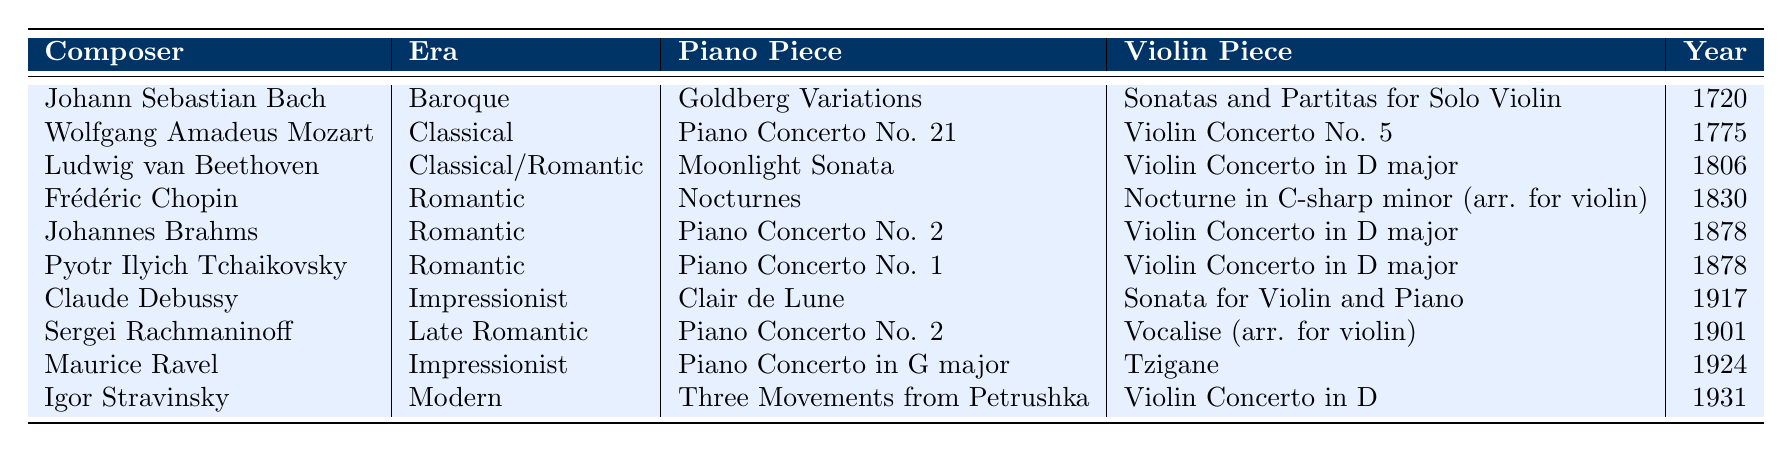What composer created the "Moonlight Sonata"? By looking at the table, I can see that "Moonlight Sonata" is associated with Ludwig van Beethoven.
Answer: Ludwig van Beethoven In which era was the "Violin Concerto in D major" composed? The table lists "Violin Concerto in D major" under both Johannes Brahms and Pyotr Ilyich Tchaikovsky, who are both in the Romantic era.
Answer: Romantic Which piece for piano was composed in 1830? Referring to the table, I find that Frédéric Chopin's "Nocturnes" was composed in 1830.
Answer: Nocturnes Who is the composer of "Clair de Lune"? The table indicates that "Clair de Lune" is by Claude Debussy.
Answer: Claude Debussy What is the earliest composition listed in the table? Checking the "Year" column, I see that Johann Sebastian Bach's "Goldberg Variations," composed in 1720, is the earliest.
Answer: 1720 Which composer has two major works listed in the table? By reviewing the entries, I find that "Violin Concerto in D major" appears for both Johannes Brahms and Pyotr Ilyich Tchaikovsky, indicating that both have two major works.
Answer: Johannes Brahms and Pyotr Ilyich Tchaikovsky Are there any composers in the table from the Impressionist era? The table mentions Claude Debussy and Maurice Ravel, both of whom are categorized under the Impressionist era.
Answer: Yes What year was the "Piano Concerto No. 1" for piano composed? According to the table, "Piano Concerto No. 1" was composed by Pyotr Ilyich Tchaikovsky in 1878.
Answer: 1878 Which piano piece was composed the latest? I can see that "Three Movements from Petrushka" by Igor Stravinsky was composed in 1931, which is the latest year in the table.
Answer: Three Movements from Petrushka How many composers listed are classified under the Romantic era? By counting the entries in the "Era" column, there are four composers listed under the Romantic era: Frédéric Chopin, Johannes Brahms, Pyotr Ilyich Tchaikovsky, and Sergei Rachmaninoff.
Answer: Four 